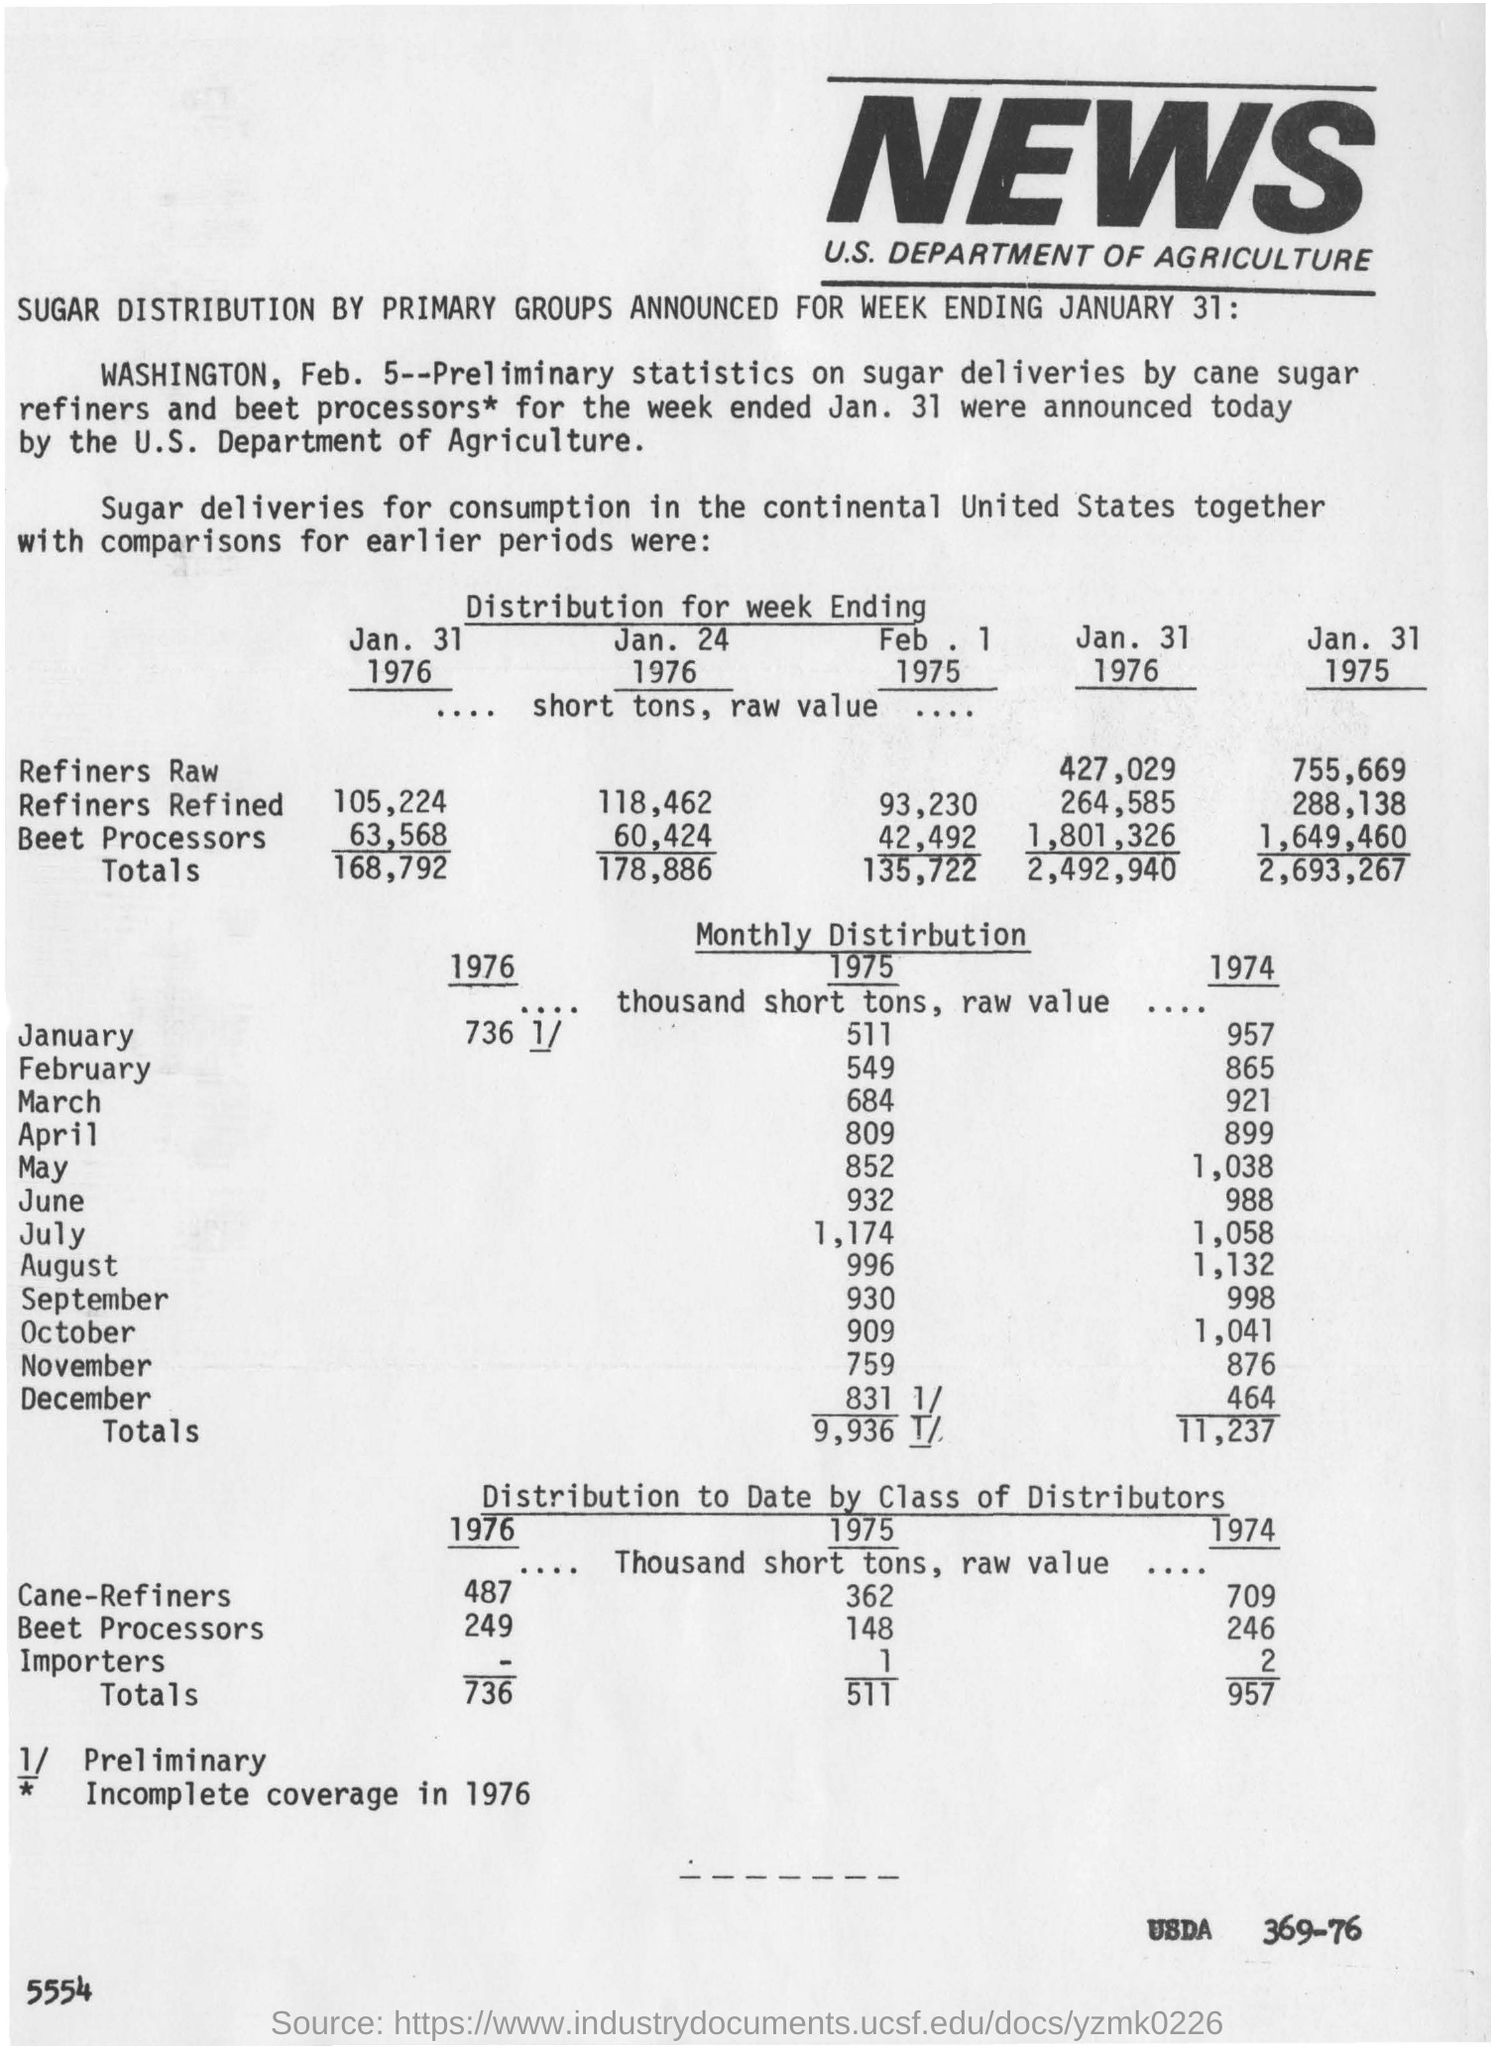Which department announced the Preliminary statistics on sugar deliveries by cane sugar refiners and beet processors?
Offer a terse response. U.S. DEPARTMENT OF AGRICULTURE. 